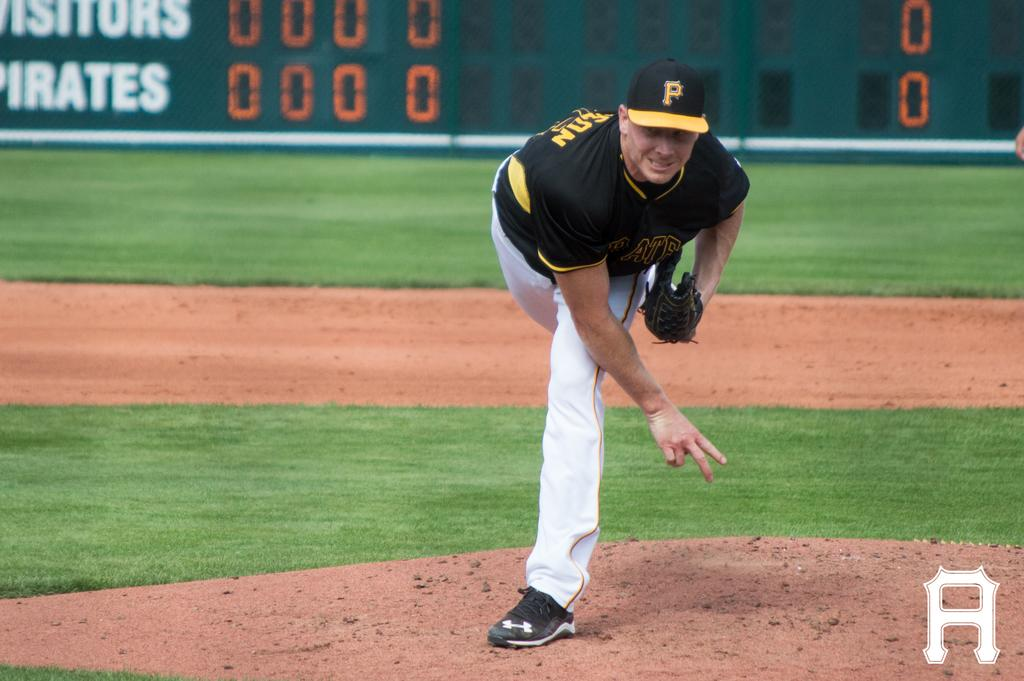<image>
Write a terse but informative summary of the picture. A baseball player wearing a black a yellow cap with the letter P on it. 